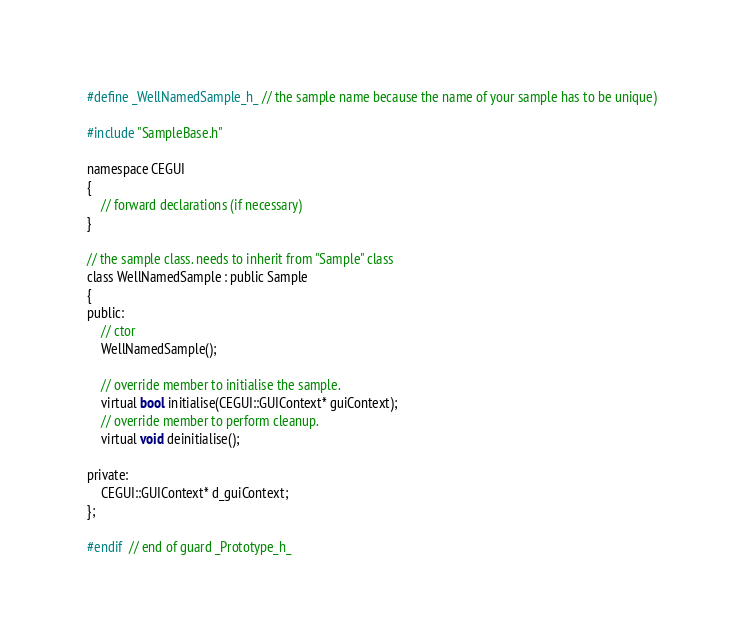Convert code to text. <code><loc_0><loc_0><loc_500><loc_500><_C_>#define _WellNamedSample_h_ // the sample name because the name of your sample has to be unique)

#include "SampleBase.h"

namespace CEGUI
{
    // forward declarations (if necessary)
}

// the sample class. needs to inherit from "Sample" class
class WellNamedSample : public Sample
{
public:
    // ctor
    WellNamedSample();

    // override member to initialise the sample.
    virtual bool initialise(CEGUI::GUIContext* guiContext);
    // override member to perform cleanup.
    virtual void deinitialise();

private:
    CEGUI::GUIContext* d_guiContext;
};

#endif  // end of guard _Prototype_h_

</code> 